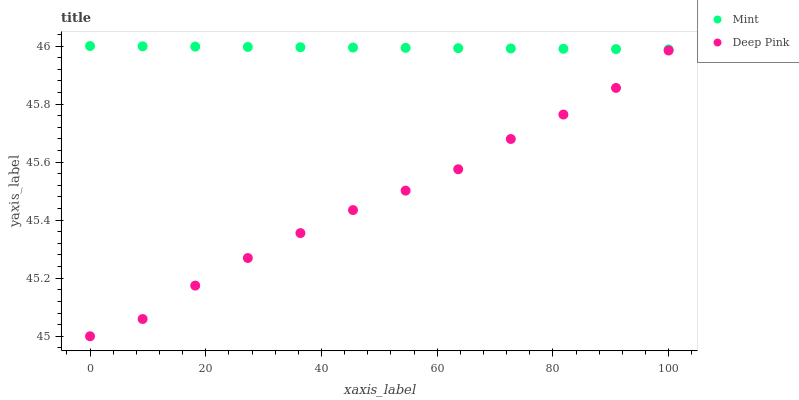Does Deep Pink have the minimum area under the curve?
Answer yes or no. Yes. Does Mint have the maximum area under the curve?
Answer yes or no. Yes. Does Mint have the minimum area under the curve?
Answer yes or no. No. Is Mint the smoothest?
Answer yes or no. Yes. Is Deep Pink the roughest?
Answer yes or no. Yes. Is Mint the roughest?
Answer yes or no. No. Does Deep Pink have the lowest value?
Answer yes or no. Yes. Does Mint have the lowest value?
Answer yes or no. No. Does Mint have the highest value?
Answer yes or no. Yes. Is Deep Pink less than Mint?
Answer yes or no. Yes. Is Mint greater than Deep Pink?
Answer yes or no. Yes. Does Deep Pink intersect Mint?
Answer yes or no. No. 